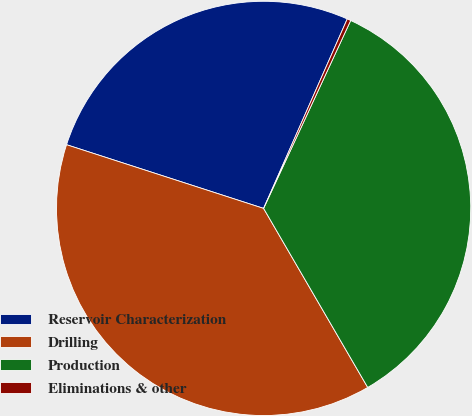Convert chart. <chart><loc_0><loc_0><loc_500><loc_500><pie_chart><fcel>Reservoir Characterization<fcel>Drilling<fcel>Production<fcel>Eliminations & other<nl><fcel>26.64%<fcel>38.36%<fcel>34.71%<fcel>0.29%<nl></chart> 